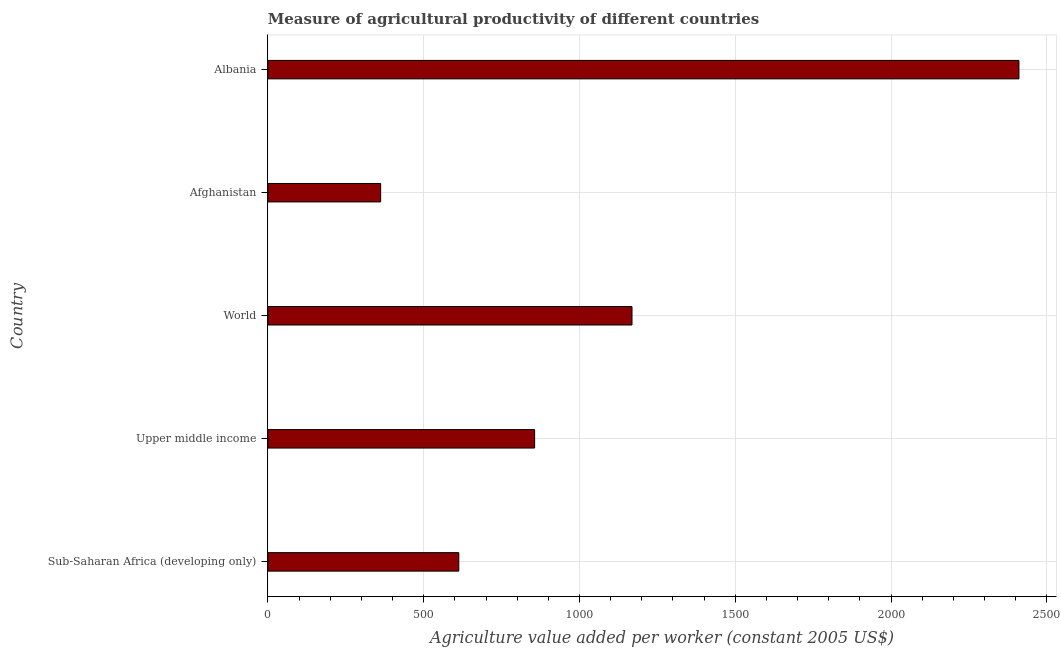Does the graph contain grids?
Your answer should be very brief. Yes. What is the title of the graph?
Ensure brevity in your answer.  Measure of agricultural productivity of different countries. What is the label or title of the X-axis?
Provide a short and direct response. Agriculture value added per worker (constant 2005 US$). What is the agriculture value added per worker in Upper middle income?
Offer a terse response. 856.05. Across all countries, what is the maximum agriculture value added per worker?
Offer a very short reply. 2410.11. Across all countries, what is the minimum agriculture value added per worker?
Provide a short and direct response. 362. In which country was the agriculture value added per worker maximum?
Your response must be concise. Albania. In which country was the agriculture value added per worker minimum?
Your answer should be compact. Afghanistan. What is the sum of the agriculture value added per worker?
Give a very brief answer. 5409.38. What is the difference between the agriculture value added per worker in Upper middle income and World?
Offer a terse response. -312.46. What is the average agriculture value added per worker per country?
Your answer should be very brief. 1081.88. What is the median agriculture value added per worker?
Make the answer very short. 856.05. In how many countries, is the agriculture value added per worker greater than 1400 US$?
Ensure brevity in your answer.  1. Is the agriculture value added per worker in Sub-Saharan Africa (developing only) less than that in World?
Give a very brief answer. Yes. Is the difference between the agriculture value added per worker in Upper middle income and World greater than the difference between any two countries?
Provide a short and direct response. No. What is the difference between the highest and the second highest agriculture value added per worker?
Give a very brief answer. 1241.6. What is the difference between the highest and the lowest agriculture value added per worker?
Your answer should be very brief. 2048.12. In how many countries, is the agriculture value added per worker greater than the average agriculture value added per worker taken over all countries?
Offer a terse response. 2. What is the Agriculture value added per worker (constant 2005 US$) of Sub-Saharan Africa (developing only)?
Your answer should be compact. 612.71. What is the Agriculture value added per worker (constant 2005 US$) of Upper middle income?
Ensure brevity in your answer.  856.05. What is the Agriculture value added per worker (constant 2005 US$) of World?
Provide a short and direct response. 1168.51. What is the Agriculture value added per worker (constant 2005 US$) of Afghanistan?
Make the answer very short. 362. What is the Agriculture value added per worker (constant 2005 US$) in Albania?
Your response must be concise. 2410.11. What is the difference between the Agriculture value added per worker (constant 2005 US$) in Sub-Saharan Africa (developing only) and Upper middle income?
Your answer should be compact. -243.34. What is the difference between the Agriculture value added per worker (constant 2005 US$) in Sub-Saharan Africa (developing only) and World?
Offer a very short reply. -555.8. What is the difference between the Agriculture value added per worker (constant 2005 US$) in Sub-Saharan Africa (developing only) and Afghanistan?
Your answer should be compact. 250.72. What is the difference between the Agriculture value added per worker (constant 2005 US$) in Sub-Saharan Africa (developing only) and Albania?
Offer a very short reply. -1797.4. What is the difference between the Agriculture value added per worker (constant 2005 US$) in Upper middle income and World?
Offer a terse response. -312.46. What is the difference between the Agriculture value added per worker (constant 2005 US$) in Upper middle income and Afghanistan?
Your response must be concise. 494.06. What is the difference between the Agriculture value added per worker (constant 2005 US$) in Upper middle income and Albania?
Your answer should be compact. -1554.06. What is the difference between the Agriculture value added per worker (constant 2005 US$) in World and Afghanistan?
Ensure brevity in your answer.  806.52. What is the difference between the Agriculture value added per worker (constant 2005 US$) in World and Albania?
Make the answer very short. -1241.6. What is the difference between the Agriculture value added per worker (constant 2005 US$) in Afghanistan and Albania?
Keep it short and to the point. -2048.12. What is the ratio of the Agriculture value added per worker (constant 2005 US$) in Sub-Saharan Africa (developing only) to that in Upper middle income?
Keep it short and to the point. 0.72. What is the ratio of the Agriculture value added per worker (constant 2005 US$) in Sub-Saharan Africa (developing only) to that in World?
Ensure brevity in your answer.  0.52. What is the ratio of the Agriculture value added per worker (constant 2005 US$) in Sub-Saharan Africa (developing only) to that in Afghanistan?
Make the answer very short. 1.69. What is the ratio of the Agriculture value added per worker (constant 2005 US$) in Sub-Saharan Africa (developing only) to that in Albania?
Your response must be concise. 0.25. What is the ratio of the Agriculture value added per worker (constant 2005 US$) in Upper middle income to that in World?
Your answer should be compact. 0.73. What is the ratio of the Agriculture value added per worker (constant 2005 US$) in Upper middle income to that in Afghanistan?
Provide a short and direct response. 2.37. What is the ratio of the Agriculture value added per worker (constant 2005 US$) in Upper middle income to that in Albania?
Your response must be concise. 0.35. What is the ratio of the Agriculture value added per worker (constant 2005 US$) in World to that in Afghanistan?
Offer a terse response. 3.23. What is the ratio of the Agriculture value added per worker (constant 2005 US$) in World to that in Albania?
Your answer should be compact. 0.48. What is the ratio of the Agriculture value added per worker (constant 2005 US$) in Afghanistan to that in Albania?
Keep it short and to the point. 0.15. 